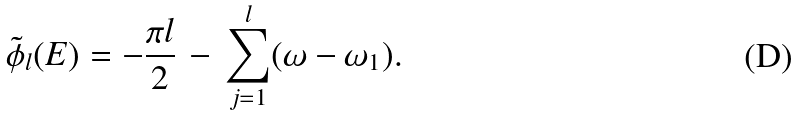<formula> <loc_0><loc_0><loc_500><loc_500>\tilde { \phi } _ { l } ( E ) = - \frac { \pi l } { 2 } \, - \, \sum _ { j = 1 } ^ { l } ( \omega - \omega _ { 1 } ) .</formula> 